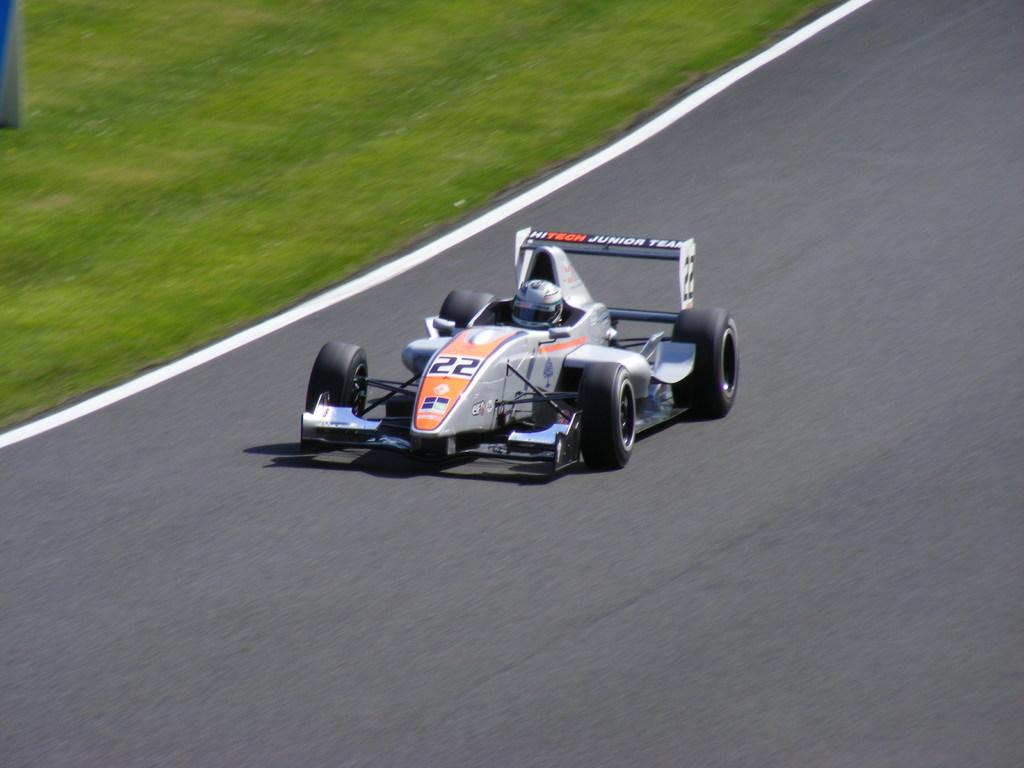What is on the road in the image? There is a vehicle on the road in the image. Who is inside the vehicle? A person is sitting in the vehicle. What is the person wearing for safety? The person is wearing a helmet. What type of landscape can be seen in the image? There is a grassland in the left top area of the image. What color is the shirt worn by the person in the ear in the image? There is no person wearing a shirt in an ear in the image; the person is wearing a helmet while sitting in the vehicle. 